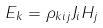<formula> <loc_0><loc_0><loc_500><loc_500>E _ { k } = \rho _ { k i j } J _ { i } H _ { j }</formula> 